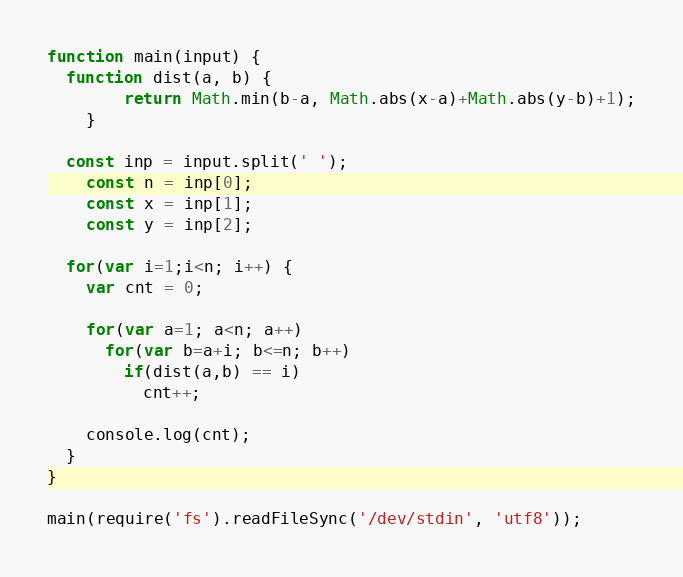<code> <loc_0><loc_0><loc_500><loc_500><_JavaScript_>function main(input) {
  function dist(a, b) {
		return Math.min(b-a, Math.abs(x-a)+Math.abs(y-b)+1);
	}
	
  const inp = input.split(' ');
	const n = inp[0];
	const x = inp[1];
	const y = inp[2];
  
  for(var i=1;i<n; i++) {
    var cnt = 0;
    
    for(var a=1; a<n; a++)
      for(var b=a+i; b<=n; b++)
        if(dist(a,b) == i)
          cnt++;
    
    console.log(cnt);
  }
}

main(require('fs').readFileSync('/dev/stdin', 'utf8'));</code> 